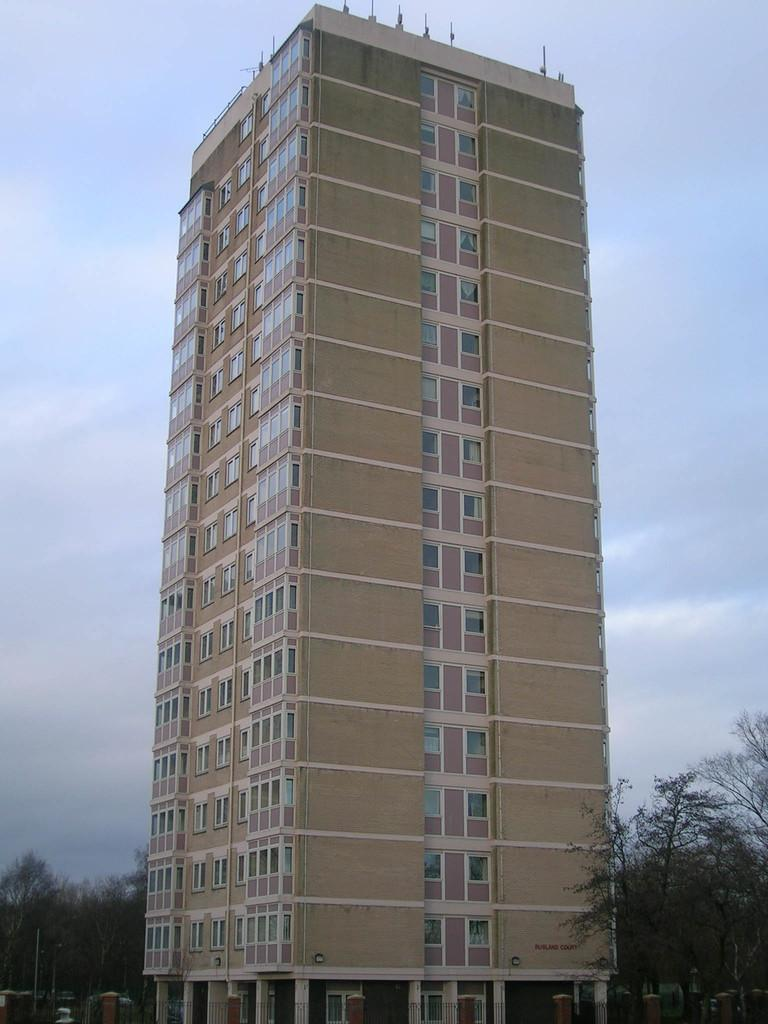What type of structure is visible in the image? There is a building in the image. What other natural elements can be seen in the image? There are trees in the image. How would you describe the weather based on the image? The sky is cloudy in the image, which suggests a potentially overcast or cloudy day. What type of glove is being used to create the cloudy effect in the image? There is no glove or any indication of a glove being used to create the cloudy effect in the image. The cloudy sky is a natural weather condition and not a result of any manipulation or object in the image. 